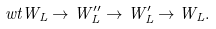Convert formula to latex. <formula><loc_0><loc_0><loc_500><loc_500>\ w t { W } _ { L } \to W _ { L } ^ { \prime \prime } \to W _ { L } ^ { \prime } \to W _ { L } .</formula> 